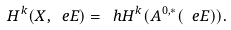Convert formula to latex. <formula><loc_0><loc_0><loc_500><loc_500>H ^ { k } ( X , \ e E ) = \ h H ^ { k } ( A ^ { 0 , \ast } ( \ e E ) ) .</formula> 